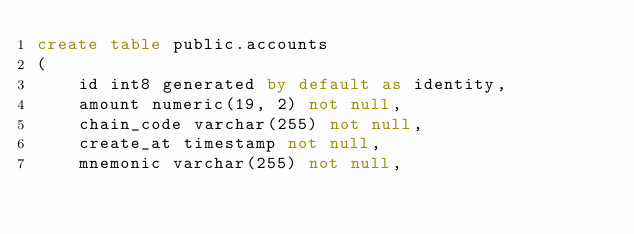Convert code to text. <code><loc_0><loc_0><loc_500><loc_500><_SQL_>create table public.accounts
(
    id int8 generated by default as identity,
    amount numeric(19, 2) not null,
    chain_code varchar(255) not null,
    create_at timestamp not null,
    mnemonic varchar(255) not null,</code> 